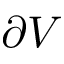Convert formula to latex. <formula><loc_0><loc_0><loc_500><loc_500>\partial V</formula> 